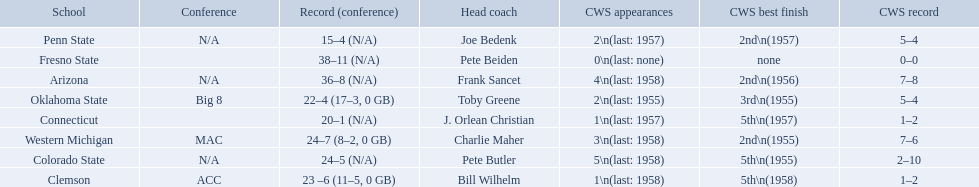What was the least amount of wins recorded by the losingest team? 15–4 (N/A). Which team held this record? Penn State. What are all the school names? Arizona, Clemson, Colorado State, Connecticut, Fresno State, Oklahoma State, Penn State, Western Michigan. Can you give me this table as a dict? {'header': ['School', 'Conference', 'Record (conference)', 'Head coach', 'CWS appearances', 'CWS best finish', 'CWS record'], 'rows': [['Penn State', 'N/A', '15–4 (N/A)', 'Joe Bedenk', '2\\n(last: 1957)', '2nd\\n(1957)', '5–4'], ['Fresno State', '', '38–11 (N/A)', 'Pete Beiden', '0\\n(last: none)', 'none', '0–0'], ['Arizona', 'N/A', '36–8 (N/A)', 'Frank Sancet', '4\\n(last: 1958)', '2nd\\n(1956)', '7–8'], ['Oklahoma State', 'Big 8', '22–4 (17–3, 0 GB)', 'Toby Greene', '2\\n(last: 1955)', '3rd\\n(1955)', '5–4'], ['Connecticut', '', '20–1 (N/A)', 'J. Orlean Christian', '1\\n(last: 1957)', '5th\\n(1957)', '1–2'], ['Western Michigan', 'MAC', '24–7 (8–2, 0 GB)', 'Charlie Maher', '3\\n(last: 1958)', '2nd\\n(1955)', '7–6'], ['Colorado State', 'N/A', '24–5 (N/A)', 'Pete Butler', '5\\n(last: 1958)', '5th\\n(1955)', '2–10'], ['Clemson', 'ACC', '23 –6 (11–5, 0 GB)', 'Bill Wilhelm', '1\\n(last: 1958)', '5th\\n(1958)', '1–2']]} What is the record for each? 36–8 (N/A), 23 –6 (11–5, 0 GB), 24–5 (N/A), 20–1 (N/A), 38–11 (N/A), 22–4 (17–3, 0 GB), 15–4 (N/A), 24–7 (8–2, 0 GB). Which school had the fewest number of wins? Penn State. 